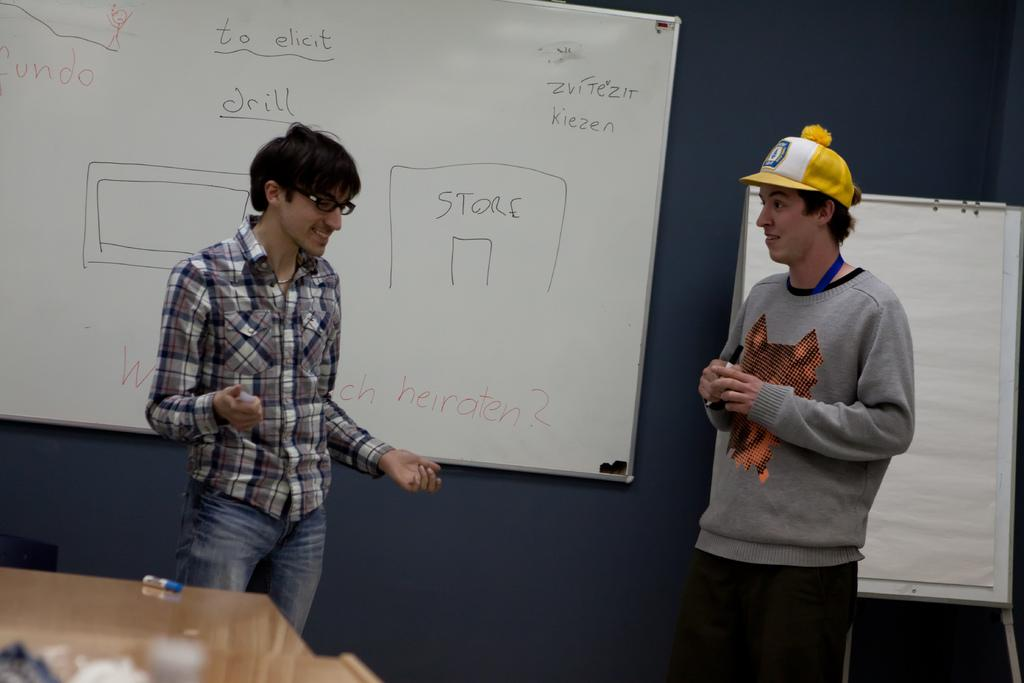<image>
Write a terse but informative summary of the picture. Two men are standing in front of a white board that says "drill." 